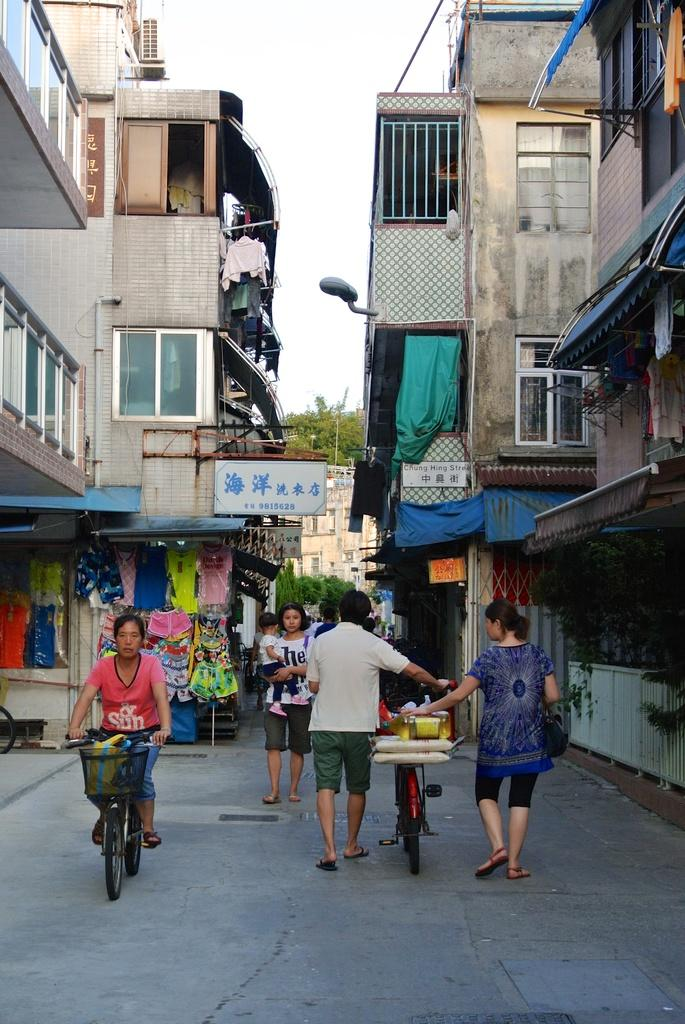What can be seen in the image that people walk on? There is a path in the image that people walk on. Can you describe the people on the path? There are people on the path in the image. What is visible in the distance behind the path? There are buildings, a street light, and trees in the background of the image. What might be used for drying clothes in the image? Clothes are visible in the image, which suggests they are being dried. How does the toe of the person on the path increase in size in the image? There is no toe visible in the image, and therefore no change in size can be observed. 